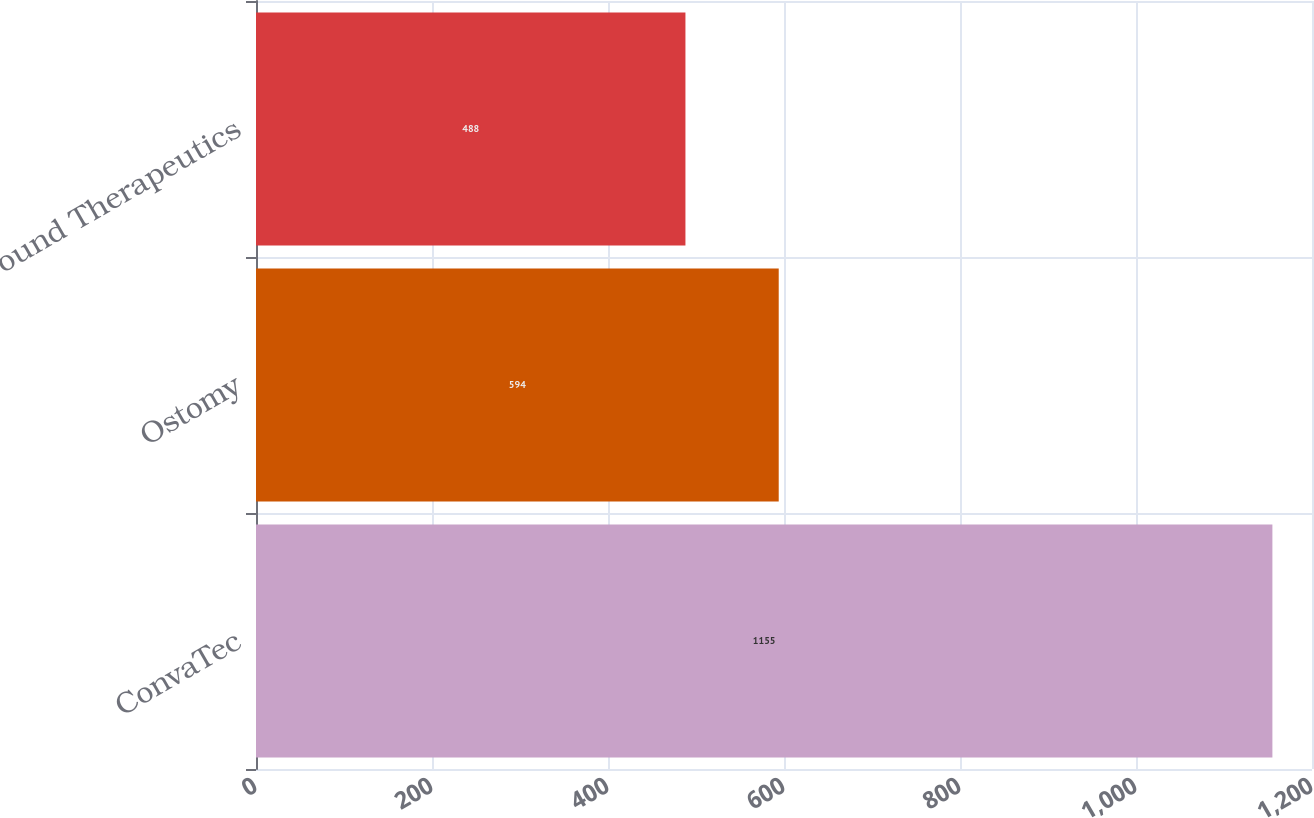Convert chart. <chart><loc_0><loc_0><loc_500><loc_500><bar_chart><fcel>ConvaTec<fcel>Ostomy<fcel>Wound Therapeutics<nl><fcel>1155<fcel>594<fcel>488<nl></chart> 